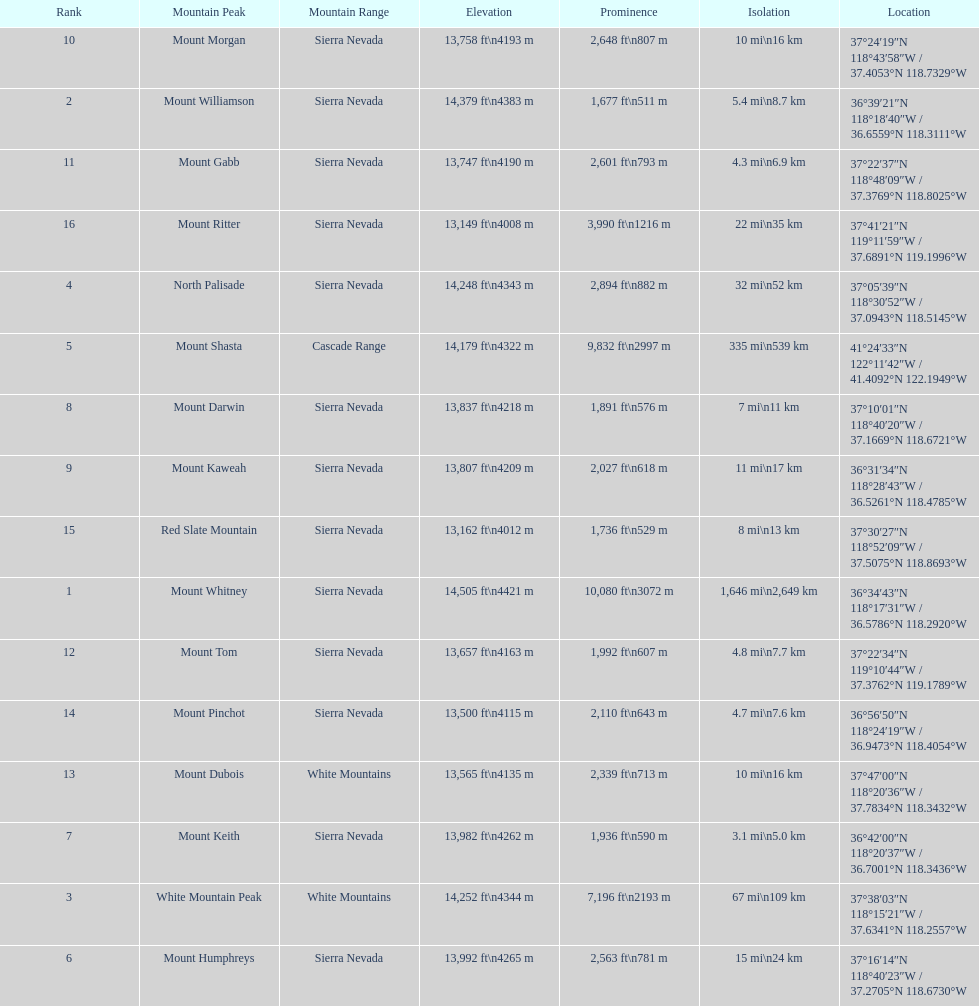Which is taller, mount humphreys or mount kaweah. Mount Humphreys. 